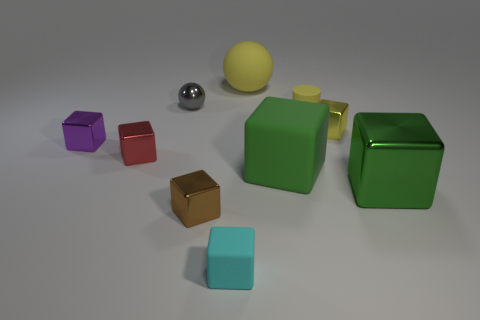Subtract all purple blocks. How many blocks are left? 6 Subtract all green blocks. How many blocks are left? 5 Subtract 3 blocks. How many blocks are left? 4 Subtract all purple blocks. Subtract all brown spheres. How many blocks are left? 6 Subtract all blocks. How many objects are left? 3 Add 4 large objects. How many large objects are left? 7 Add 4 tiny gray metal cylinders. How many tiny gray metal cylinders exist? 4 Subtract 0 red cylinders. How many objects are left? 10 Subtract all large green blocks. Subtract all purple metallic cubes. How many objects are left? 7 